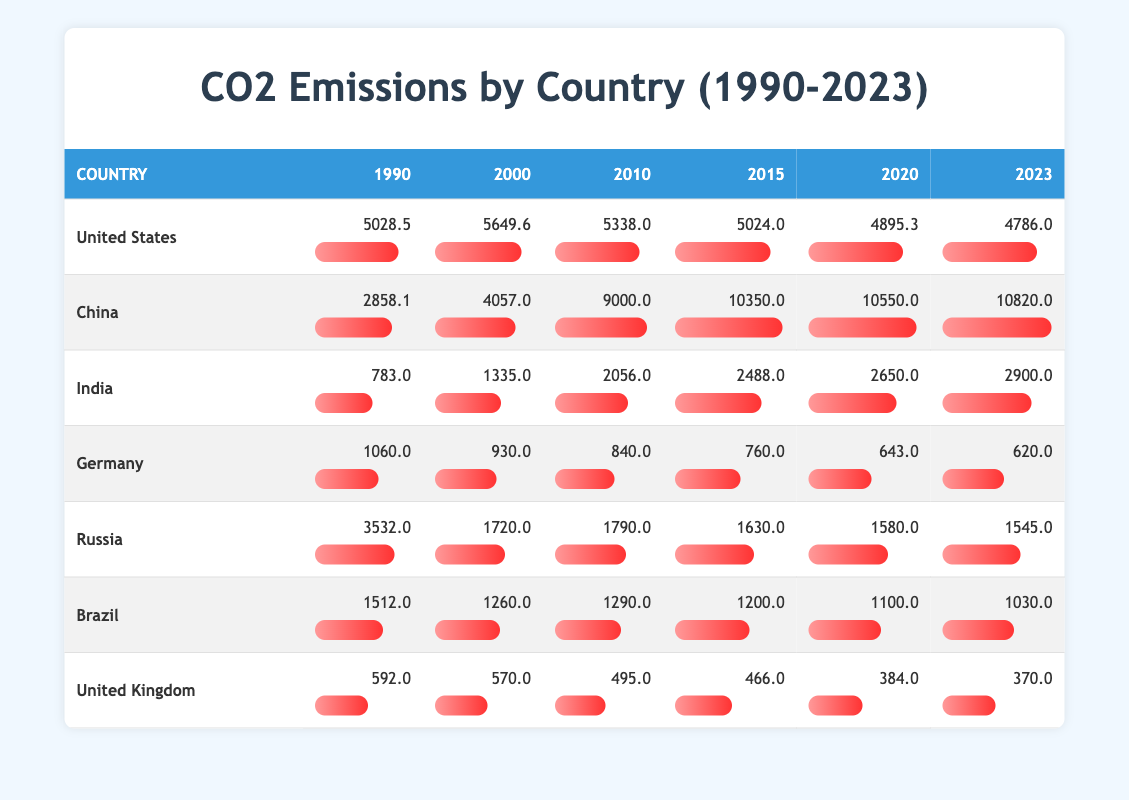What was the CO2 emission for China in 2010? The table shows the CO2 emissions for China in 2010 as 9000.0. This value can be found in the row for China under the column for the year 2010.
Answer: 9000.0 What country had the highest CO2 emission in 2020? In the 2020 column of the table, China has the highest CO2 emission at 10550.0, compared to the other countries listed.
Answer: China How much did the United States CO2 emissions decrease from 1990 to 2023? The emissions in 1990 were 5028.5, and by 2023 it was 4786.0. The decrease is calculated as 5028.5 - 4786.0 = 242.5.
Answer: 242.5 Was the CO2 emission for Germany lower in 2023 than it was in 1990? In 1990, Germany's CO2 emissions were 1060.0, whereas in 2023 they were 620.0. Since 620.0 is lower than 1060.0, the statement is true.
Answer: Yes What is the average CO2 emission for India from 1990 to 2023? To find the average, we sum India's emissions from each year: (783.0 + 1335.0 + 2056.0 + 2488.0 + 2650.0 + 2900.0) = 11312.0, then divide by 6 (the number of years) resulting in approximately 1885.33.
Answer: 1885.33 Which country had the largest reduction in CO2 emissions from 2000 to 2023? For each country, we calculate the difference between 2000 and 2023 emissions: United States (5649.6 - 4786.0 = 863.6), China (4057.0 - 10820.0 = -6763.0), India (1335.0 - 2900.0 = -1565.0), Germany (930.0 - 620.0 = 310.0), Russia (1720.0 - 1545.0 = 175.0), Brazil (1260.0 - 1030.0 = 230.0), UK (570.0 - 370.0 = 200.0). The largest reduction is 863.6 for the United States.
Answer: United States Is it true that Brazil's emissions in 2020 were higher than Germany's in the same year? Brazil's emissions in 2020 were 1100.0, and Germany's were 643.0. Since 1100.0 is greater than 643.0, the statement is true.
Answer: Yes What was the percentage change in CO2 emissions for Russia from 1990 to 2023? Russia's emissions in 1990 were 3532.0, and in 2023 they were 1545.0. The change is (1545.0 - 3532.0) / 3532.0 * 100 = -56.27%.
Answer: -56.27% 